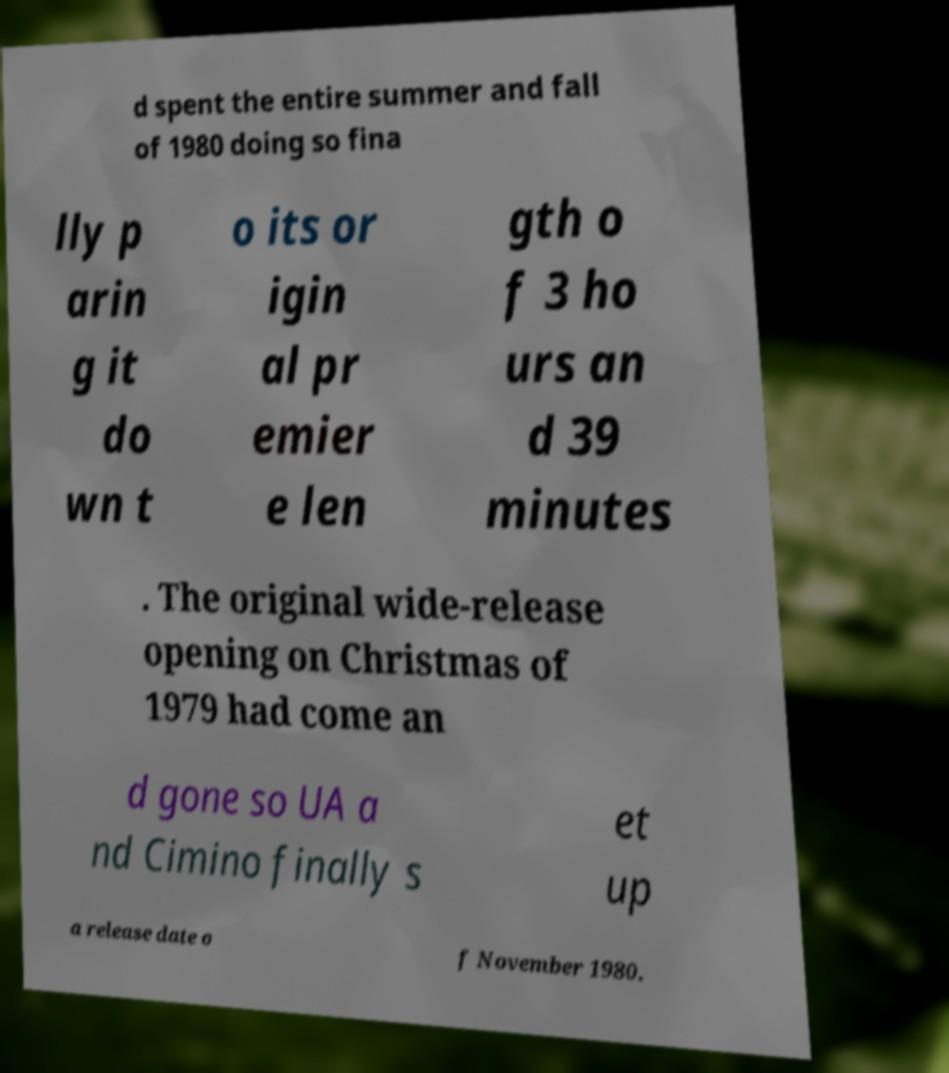Can you read and provide the text displayed in the image?This photo seems to have some interesting text. Can you extract and type it out for me? d spent the entire summer and fall of 1980 doing so fina lly p arin g it do wn t o its or igin al pr emier e len gth o f 3 ho urs an d 39 minutes . The original wide-release opening on Christmas of 1979 had come an d gone so UA a nd Cimino finally s et up a release date o f November 1980. 